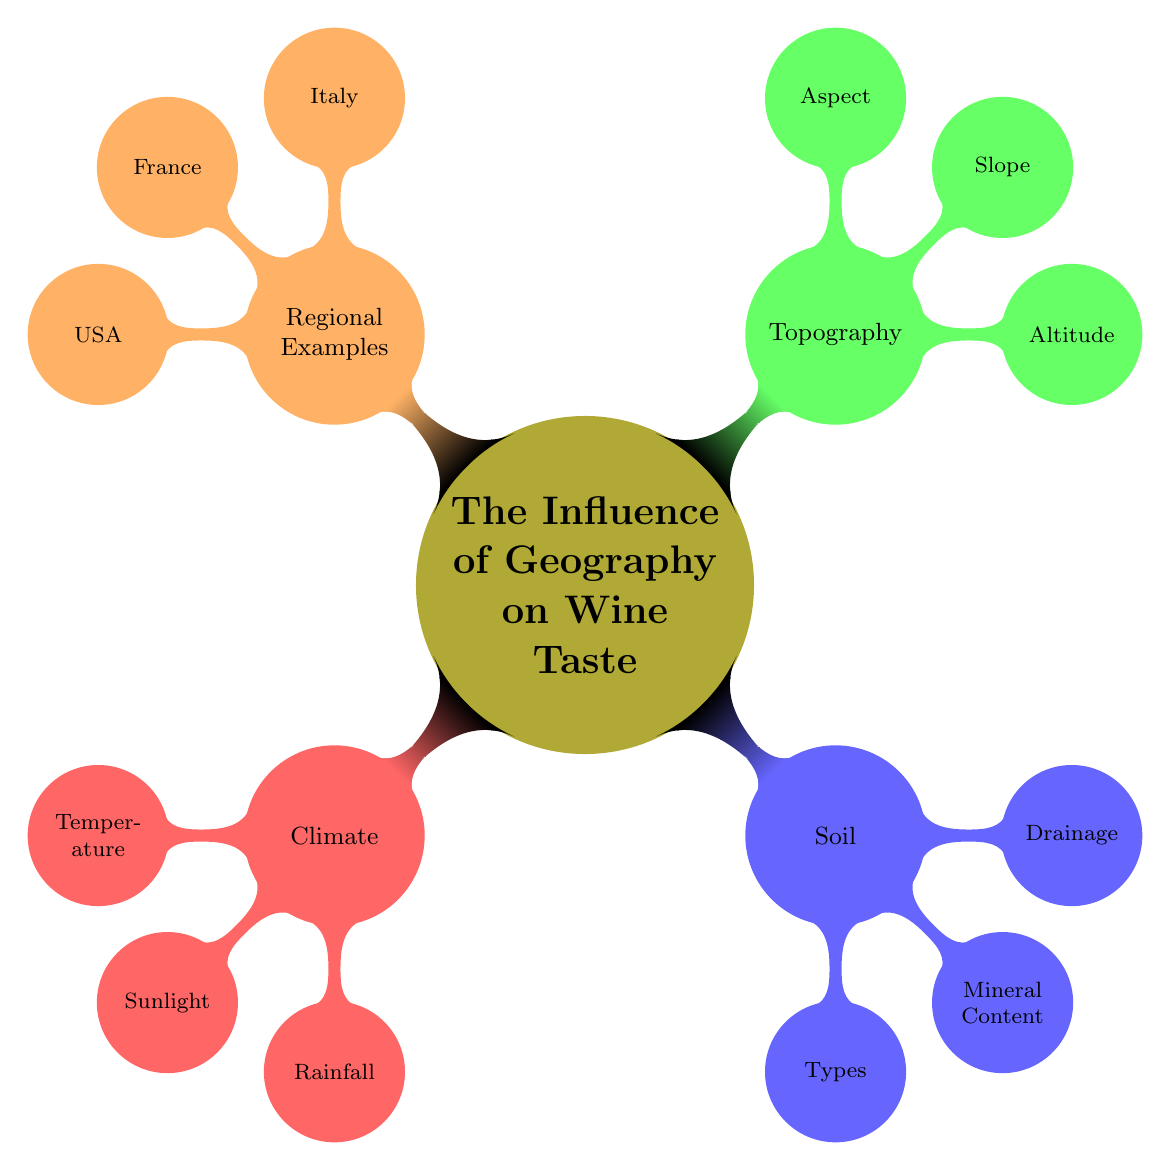What are the three main categories influencing wine taste? The diagram categorizes the influences on wine taste into Climate, Soil, Topography, and Regional Examples. By identifying the main branches from the central node, we see these four categories.
Answer: Climate, Soil, Topography, Regional Examples Which node under Climate refers to sunlight type? Under the Climate category, the sunlight types are specified as Mediterranean Sunlight and Continental Sunlight. This can be found by looking at the nodes directly connected to the Climate node, and specifically the Sunlight node.
Answer: Sunlight What types of soil are listed in the diagram? The Soil node contains a sub-node labeled Types, which lists Limestone, Volcanic, and Clay as the specific types of soil. This is derived by exploring the subnodes under Soil.
Answer: Limestone, Volcanic, Clay How many regional examples are provided for Italy? The Regional Examples node contains sub-nodes for specific regions, which indicates that Italy is listed with Chianti, Barolo, and Etna, totaling three examples. The count of sub-nodes directly under the Italy node confirms this.
Answer: 3 If a region is in a dry climate, which rainfall category would it belong to? The dry climate is mentioned under the Rainfall node as a part of the broader Climate category, indicating a connection between rainfall and the climate type, thus placing dry climate regions under Dry Regions.
Answer: Dry Regions What type of slope is mentioned under Topography? The Topography node lists Slope as one of its components, which specifically identifies Steep Slopes and Gentle Slopes. This can be reasoned by examining the properties associated with the Slope node.
Answer: Steep Slopes, Gentle Slopes Which country is associated with Napa Valley? The Napa Valley is specifically listed under the USA node in the Regional Examples section. By locating the USA category and looking for sub-nodes, Napa Valley can be identified.
Answer: USA Which aspect allows for southern exposure? The Topography category includes Aspect which has Southern Exposure and Northern Exposure as listed options. This establishes that Southern Exposure refers to a favorable aspect defined in the diagram.
Answer: Southern Exposure 